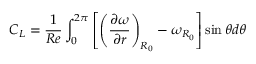<formula> <loc_0><loc_0><loc_500><loc_500>C _ { L } = \frac { 1 } { R e } \int _ { 0 } ^ { 2 \pi } \left [ \left ( \frac { \partial \omega } { \partial r } \right ) _ { R _ { 0 } } - \omega _ { R _ { 0 } } \right ] \sin { \theta } d \theta</formula> 